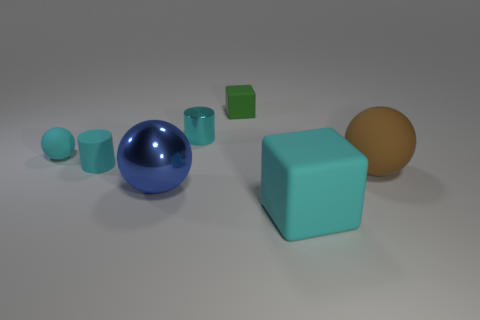Is there a tiny green rubber object that has the same shape as the big brown rubber thing?
Ensure brevity in your answer.  No. What is the shape of the brown object that is the same size as the shiny sphere?
Offer a very short reply. Sphere. Is the number of objects that are left of the tiny matte cylinder the same as the number of cyan metallic cylinders that are behind the big blue sphere?
Offer a very short reply. Yes. There is a rubber sphere that is to the right of the cyan sphere that is to the left of the big rubber cube; what is its size?
Ensure brevity in your answer.  Large. Is there a blue rubber thing that has the same size as the cyan matte ball?
Offer a terse response. No. There is a large sphere that is made of the same material as the small cyan ball; what color is it?
Offer a terse response. Brown. Is the number of cyan blocks less than the number of red rubber spheres?
Your answer should be very brief. No. There is a cyan thing that is on the right side of the blue shiny thing and to the left of the big cyan rubber thing; what is its material?
Keep it short and to the point. Metal. Are there any cyan cylinders right of the cyan cylinder that is on the right side of the large blue metal object?
Provide a short and direct response. No. What number of large things are the same color as the small rubber sphere?
Your response must be concise. 1. 